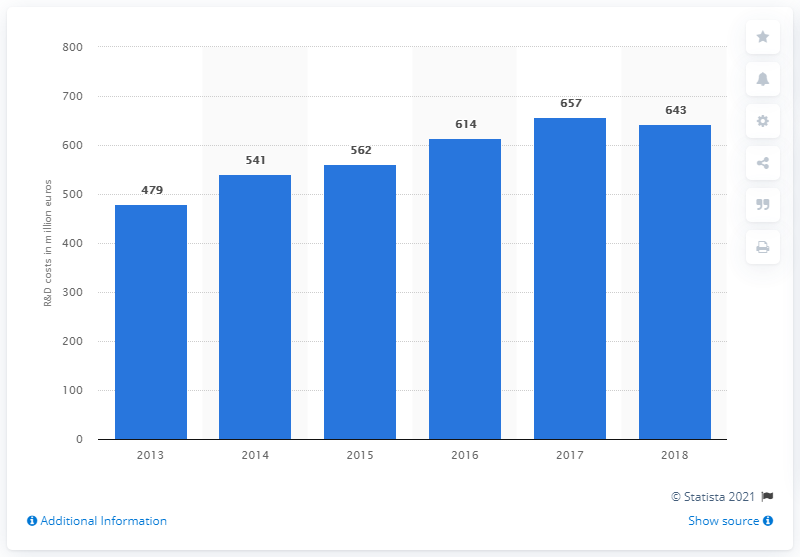What was Ferrari's R&D expenditure in 2017? In 2017, Ferrari invested 657 million euros in research and development (R&D), as indicated by the data shown in the graph. This investment is part of Ferrari's continuous effort to innovate and maintain its competitive edge in the high-performance automotive market. 